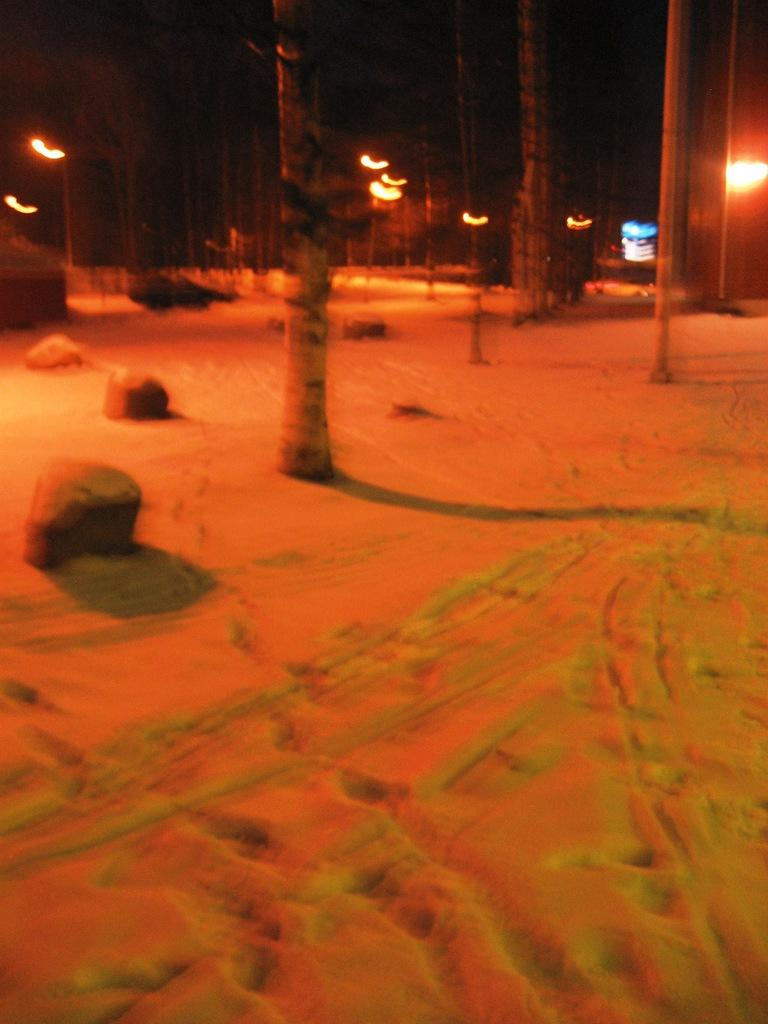What can be seen under the feet of the people or objects in the image? The ground is visible in the image. What type of natural elements are present in the image? There are rocks and trees in the image. What type of artificial elements are present in the image? There are lights in the image. Can you describe the object in the image? There is an object in the image, but its specific characteristics are not mentioned in the provided facts. What type of muscle can be seen flexing in the image? There is no muscle visible in the image. What type of riddle is depicted on the object in the image? There is no riddle present in the image, as the specific characteristics of the object are not mentioned in the provided facts. 